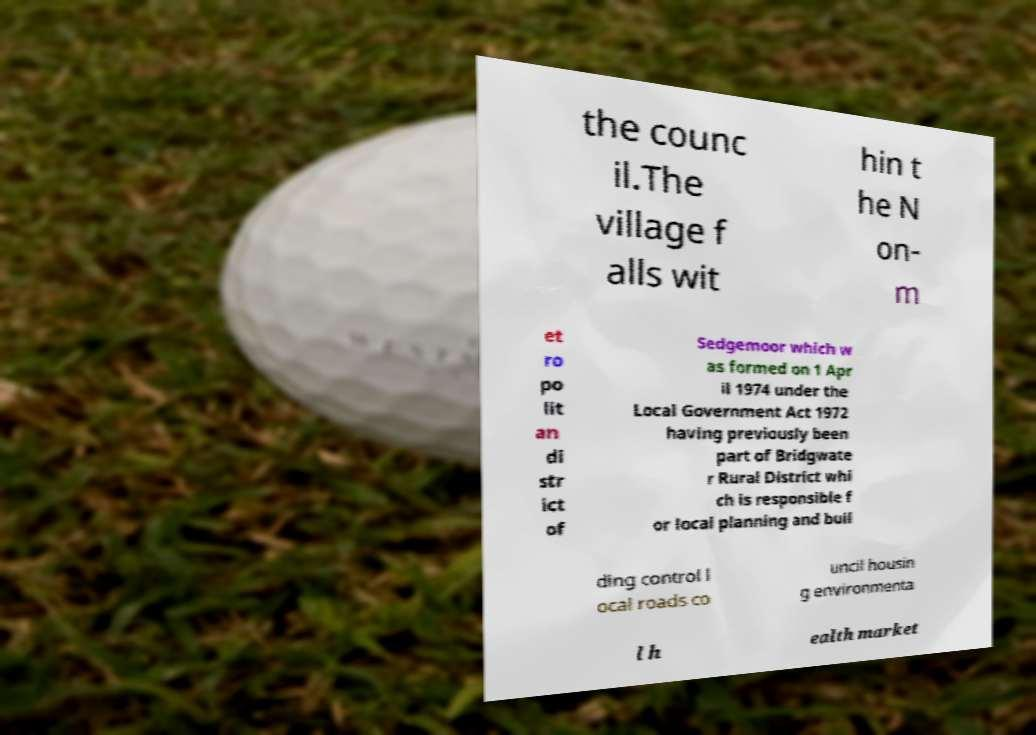Can you read and provide the text displayed in the image?This photo seems to have some interesting text. Can you extract and type it out for me? the counc il.The village f alls wit hin t he N on- m et ro po lit an di str ict of Sedgemoor which w as formed on 1 Apr il 1974 under the Local Government Act 1972 having previously been part of Bridgwate r Rural District whi ch is responsible f or local planning and buil ding control l ocal roads co uncil housin g environmenta l h ealth market 